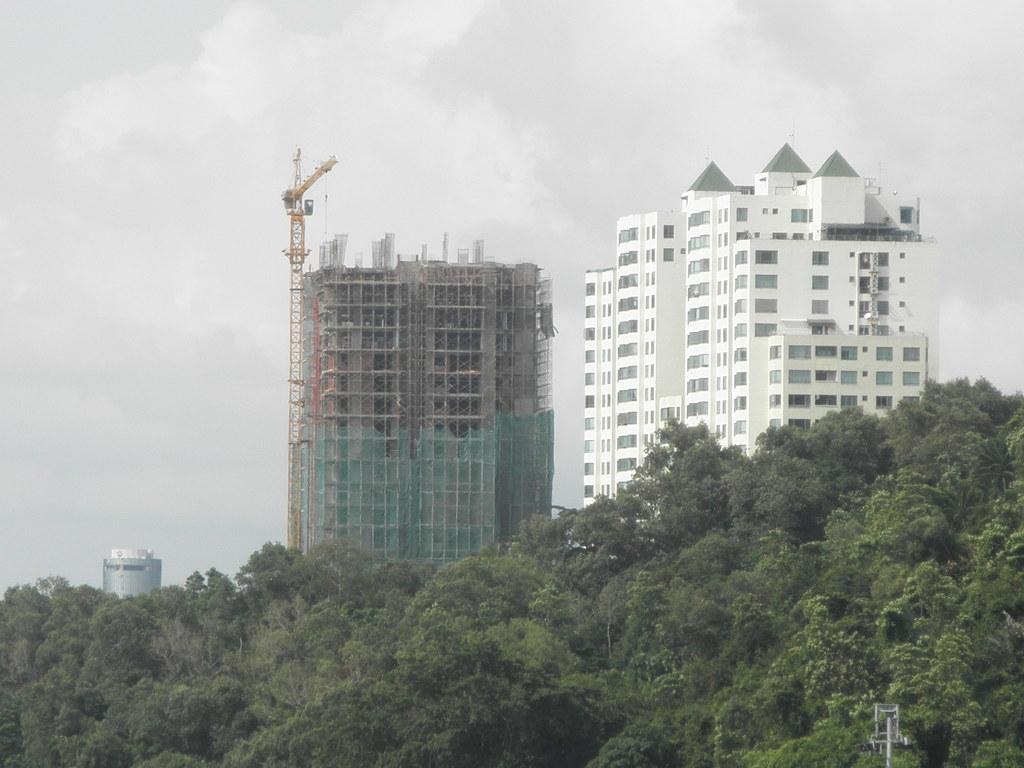What type of structures can be seen in the image? There are buildings in the image. What else is present in the image besides buildings? There are many plants in the image. Can you describe the pole at the bottom of the image? Yes, there is a pole at the bottom of the image. What is the condition of the sky in the image? The sky is cloudy in the image. How many dolls are sitting on the ice in the image? There are no dolls or ice present in the image. 